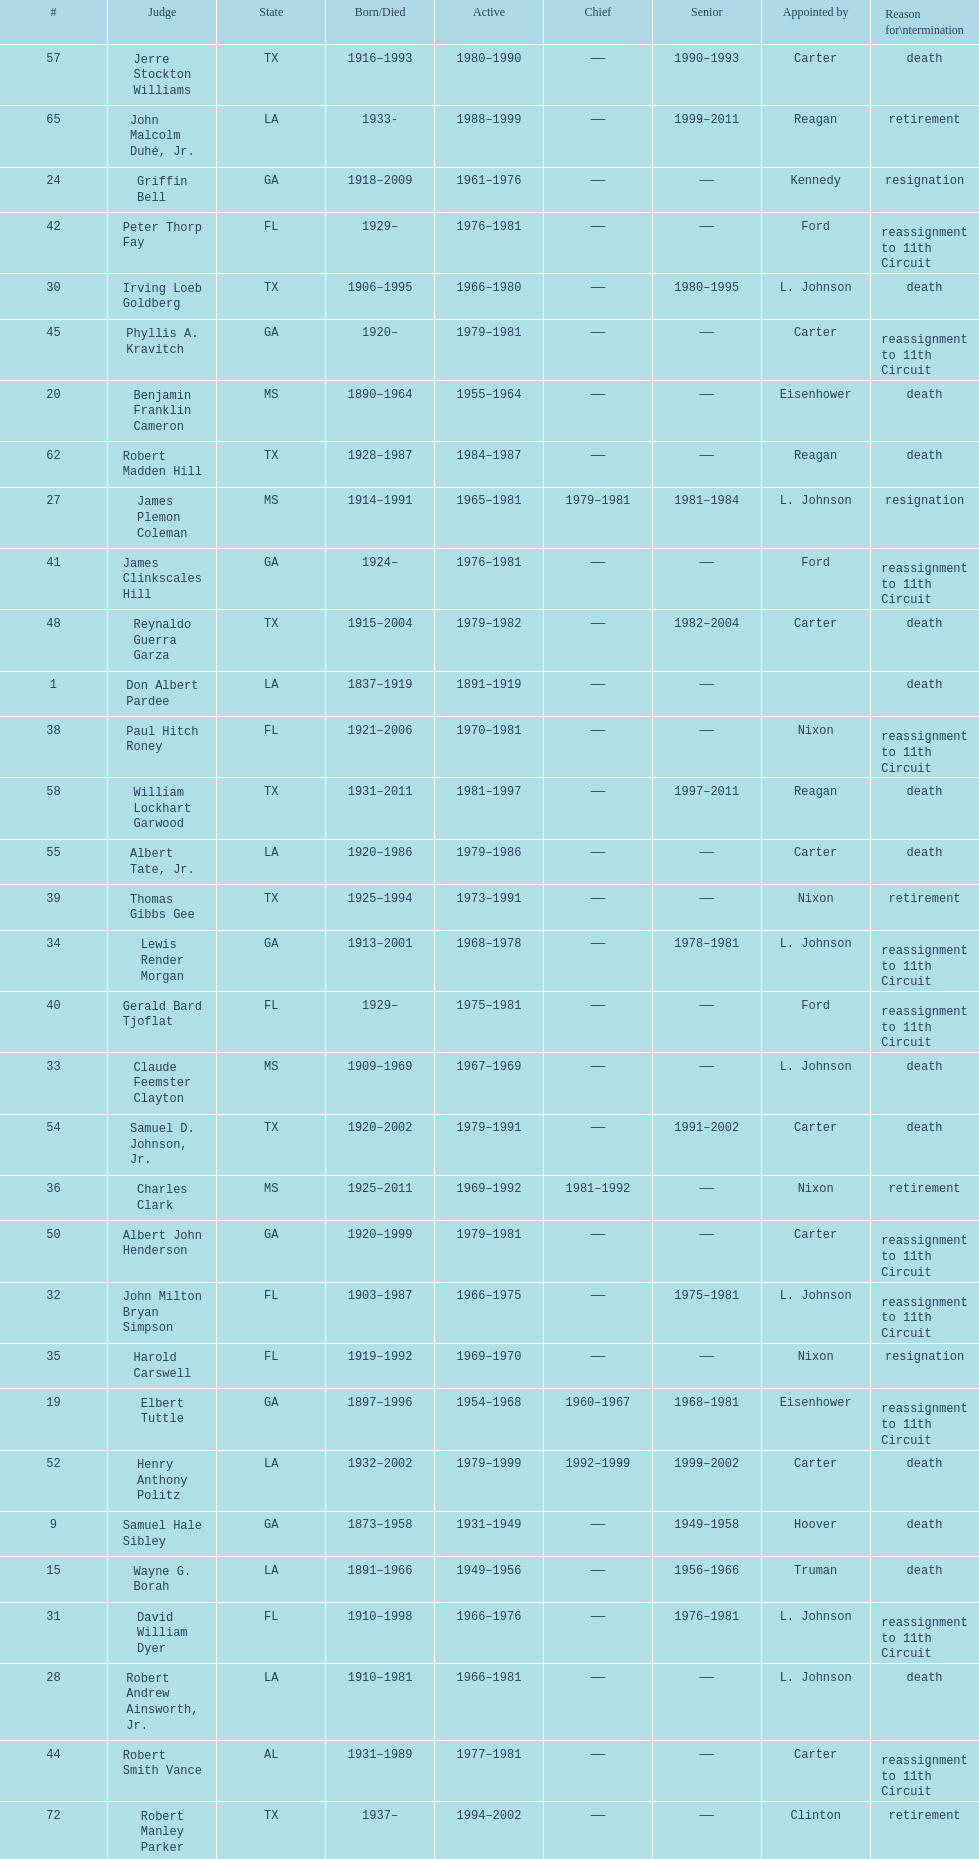Who was the only judge appointed by mckinley? David Davie Shelby. 